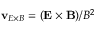<formula> <loc_0><loc_0><loc_500><loc_500>v _ { E \times B } = ( E \times B ) / B ^ { 2 }</formula> 